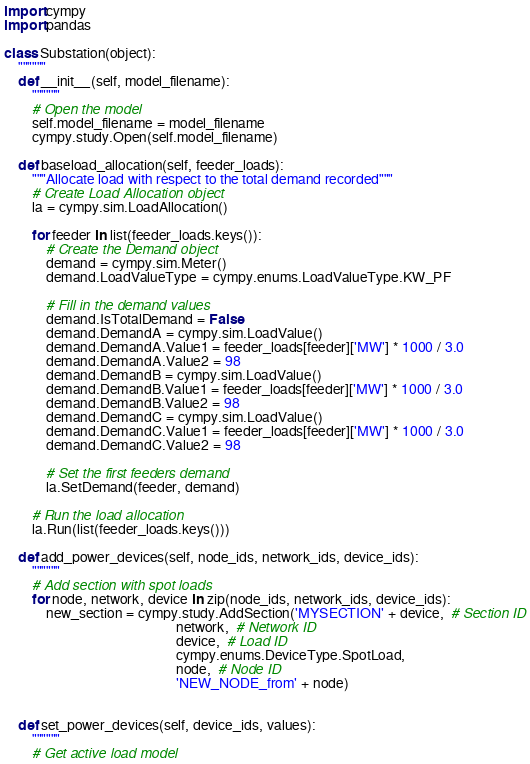Convert code to text. <code><loc_0><loc_0><loc_500><loc_500><_Python_>import cympy
import pandas

class Substation(object):
    """"""
    def __init__(self, model_filename):
        """"""
        # Open the model
        self.model_filename = model_filename
        cympy.study.Open(self.model_filename)

    def baseload_allocation(self, feeder_loads):
        """Allocate load with respect to the total demand recorded"""
        # Create Load Allocation object
        la = cympy.sim.LoadAllocation()

        for feeder in list(feeder_loads.keys()):
            # Create the Demand object
            demand = cympy.sim.Meter()
            demand.LoadValueType = cympy.enums.LoadValueType.KW_PF

            # Fill in the demand values
            demand.IsTotalDemand = False
            demand.DemandA = cympy.sim.LoadValue()
            demand.DemandA.Value1 = feeder_loads[feeder]['MW'] * 1000 / 3.0
            demand.DemandA.Value2 = 98
            demand.DemandB = cympy.sim.LoadValue()
            demand.DemandB.Value1 = feeder_loads[feeder]['MW'] * 1000 / 3.0
            demand.DemandB.Value2 = 98
            demand.DemandC = cympy.sim.LoadValue()
            demand.DemandC.Value1 = feeder_loads[feeder]['MW'] * 1000 / 3.0
            demand.DemandC.Value2 = 98

            # Set the first feeders demand
            la.SetDemand(feeder, demand)

        # Run the load allocation
        la.Run(list(feeder_loads.keys()))

    def add_power_devices(self, node_ids, network_ids, device_ids):
        """"""
        # Add section with spot loads
        for node, network, device in zip(node_ids, network_ids, device_ids):
            new_section = cympy.study.AddSection('MYSECTION' + device,  # Section ID
                                                 network,  # Network ID
                                                 device,  # Load ID
                                                 cympy.enums.DeviceType.SpotLoad,
                                                 node,  # Node ID
                                                 'NEW_NODE_from' + node)


    def set_power_devices(self, device_ids, values):
        """"""
        # Get active load model</code> 